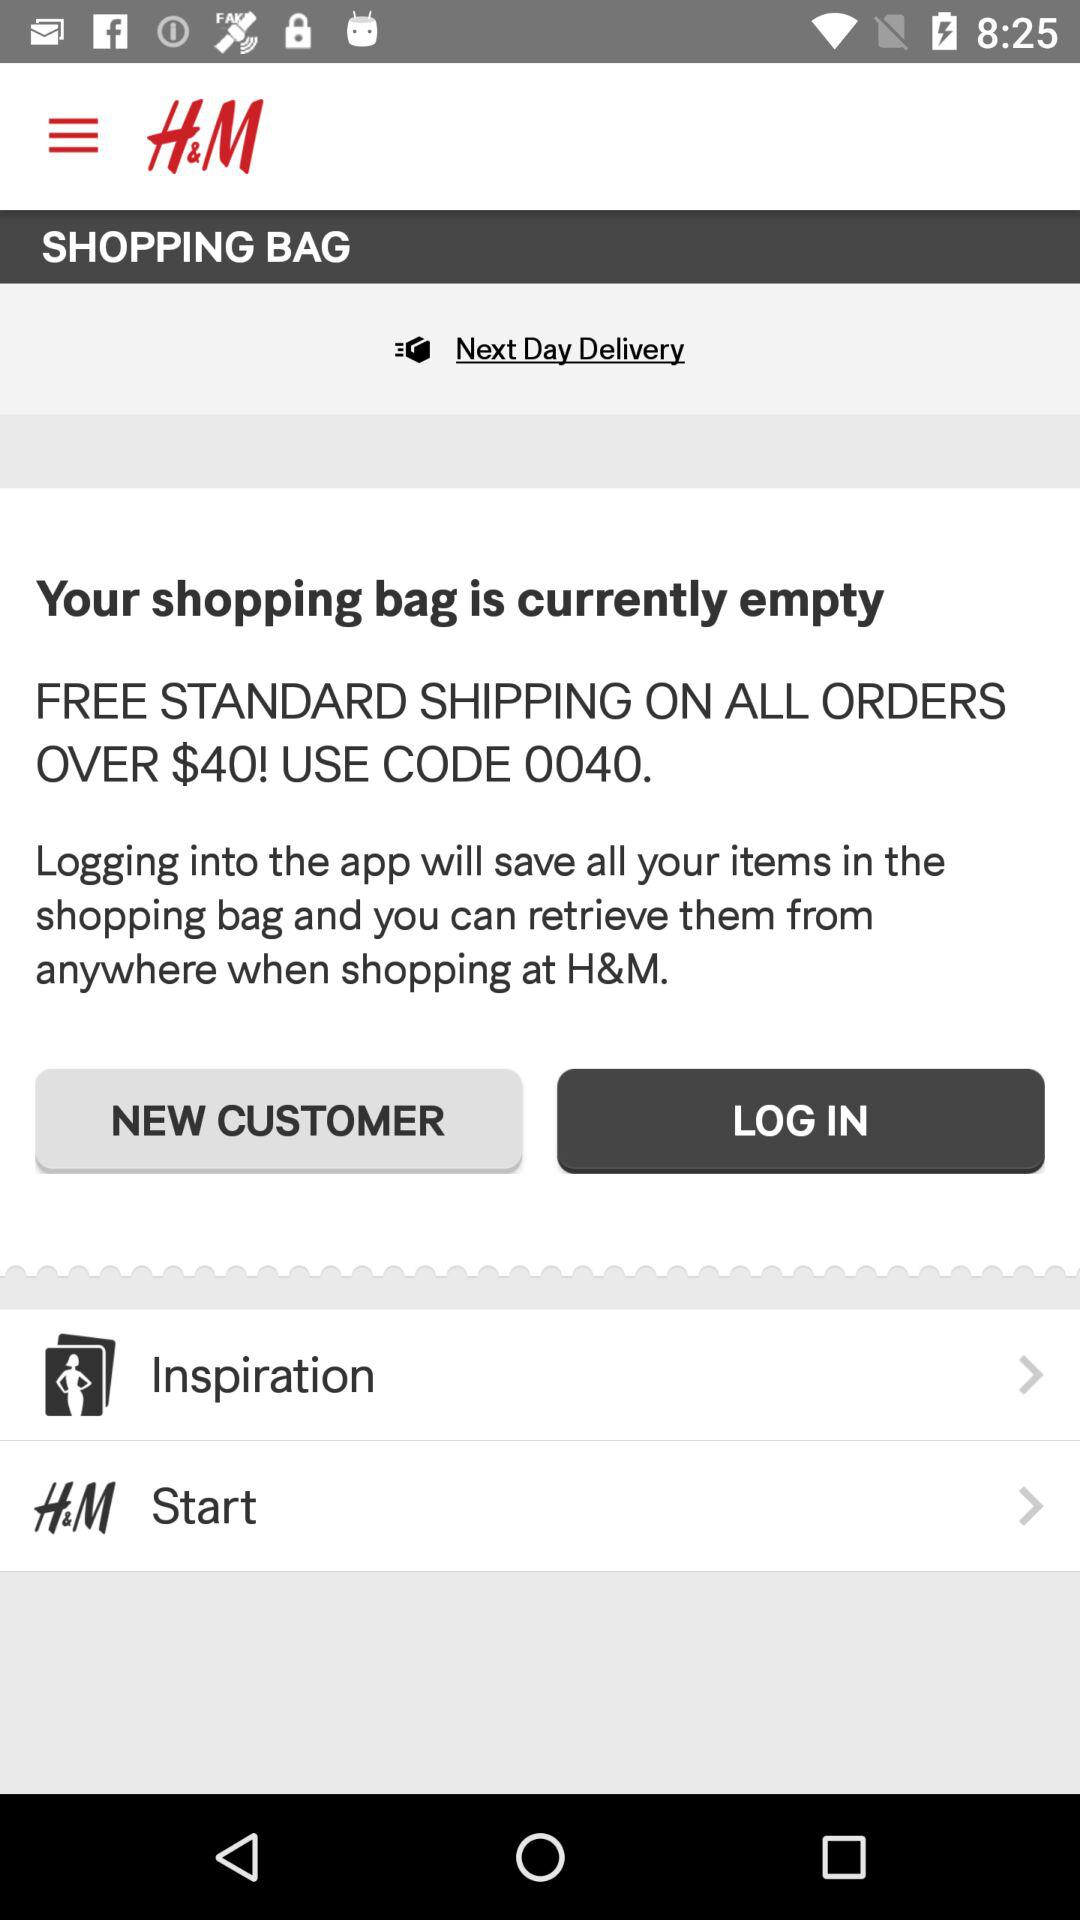How many items are in the shopping bag?
Answer the question using a single word or phrase. 0 